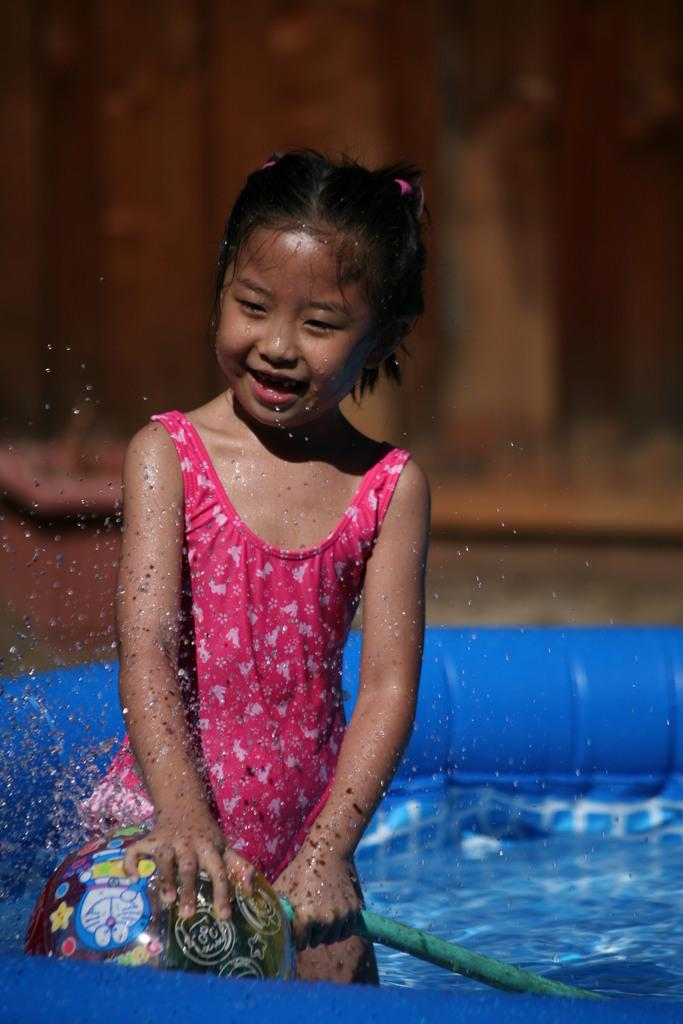Who is the main subject in the image? There is a girl in the image. What is the girl doing in the image? The girl is standing in water and holding a balloon. What is the girl's facial expression in the image? The girl is smiling. How would you describe the background of the image? The background of the image is blurred. What type of mountain can be seen in the background of the image? There is no mountain visible in the image; the background is blurred. What is the condition of the cobweb on the girl's shoulder in the image? There is no cobweb present on the girl's shoulder in the image. 